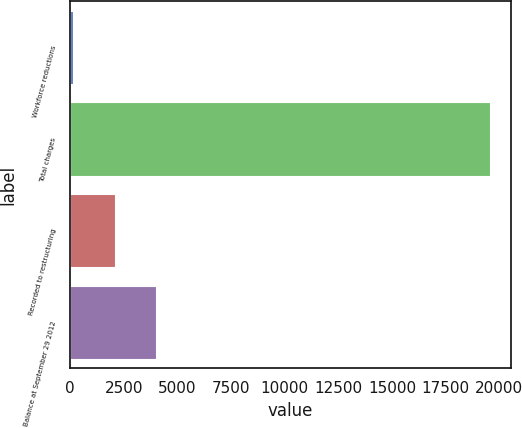<chart> <loc_0><loc_0><loc_500><loc_500><bar_chart><fcel>Workforce reductions<fcel>Total charges<fcel>Recorded to restructuring<fcel>Balance at September 29 2012<nl><fcel>128<fcel>19543<fcel>2069.5<fcel>4011<nl></chart> 